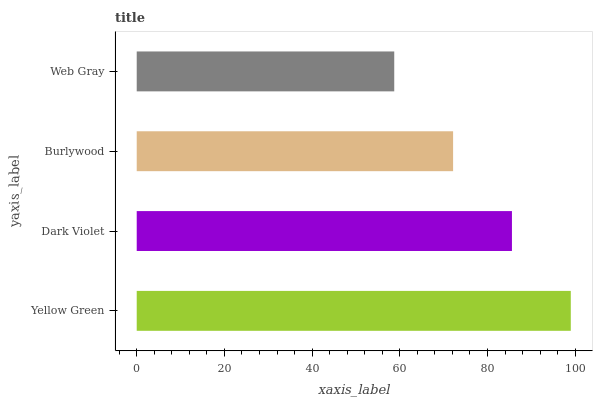Is Web Gray the minimum?
Answer yes or no. Yes. Is Yellow Green the maximum?
Answer yes or no. Yes. Is Dark Violet the minimum?
Answer yes or no. No. Is Dark Violet the maximum?
Answer yes or no. No. Is Yellow Green greater than Dark Violet?
Answer yes or no. Yes. Is Dark Violet less than Yellow Green?
Answer yes or no. Yes. Is Dark Violet greater than Yellow Green?
Answer yes or no. No. Is Yellow Green less than Dark Violet?
Answer yes or no. No. Is Dark Violet the high median?
Answer yes or no. Yes. Is Burlywood the low median?
Answer yes or no. Yes. Is Web Gray the high median?
Answer yes or no. No. Is Dark Violet the low median?
Answer yes or no. No. 